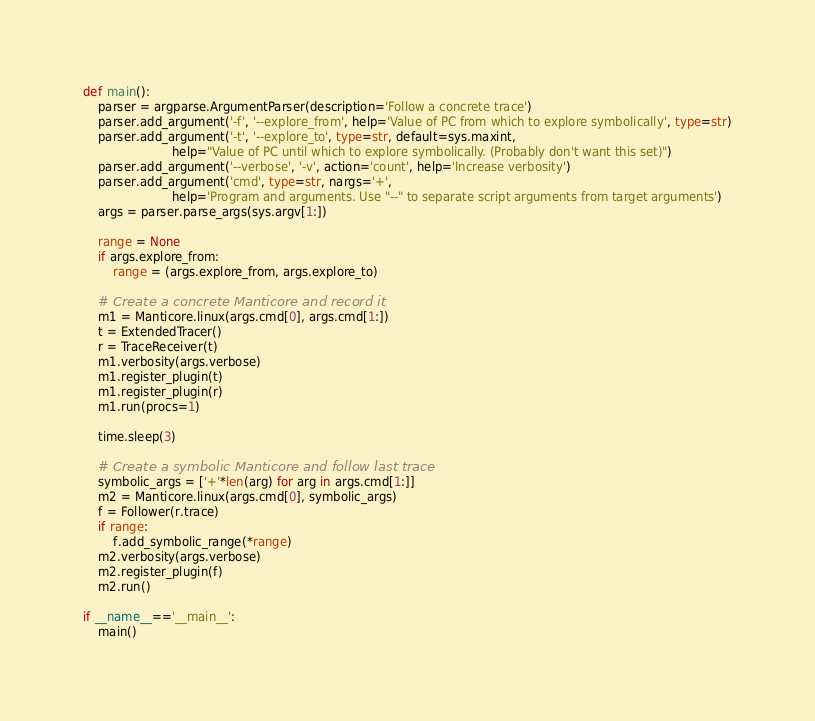<code> <loc_0><loc_0><loc_500><loc_500><_Python_>

def main():
    parser = argparse.ArgumentParser(description='Follow a concrete trace')
    parser.add_argument('-f', '--explore_from', help='Value of PC from which to explore symbolically', type=str)
    parser.add_argument('-t', '--explore_to', type=str, default=sys.maxint,
                        help="Value of PC until which to explore symbolically. (Probably don't want this set)")
    parser.add_argument('--verbose', '-v', action='count', help='Increase verbosity')
    parser.add_argument('cmd', type=str, nargs='+',
                        help='Program and arguments. Use "--" to separate script arguments from target arguments')
    args = parser.parse_args(sys.argv[1:])

    range = None
    if args.explore_from:
        range = (args.explore_from, args.explore_to)

    # Create a concrete Manticore and record it
    m1 = Manticore.linux(args.cmd[0], args.cmd[1:])
    t = ExtendedTracer()
    r = TraceReceiver(t)
    m1.verbosity(args.verbose)
    m1.register_plugin(t)
    m1.register_plugin(r)
    m1.run(procs=1)

    time.sleep(3)

    # Create a symbolic Manticore and follow last trace
    symbolic_args = ['+'*len(arg) for arg in args.cmd[1:]]
    m2 = Manticore.linux(args.cmd[0], symbolic_args)
    f = Follower(r.trace)
    if range:
        f.add_symbolic_range(*range)
    m2.verbosity(args.verbose)
    m2.register_plugin(f)
    m2.run()

if __name__=='__main__':
    main()
</code> 